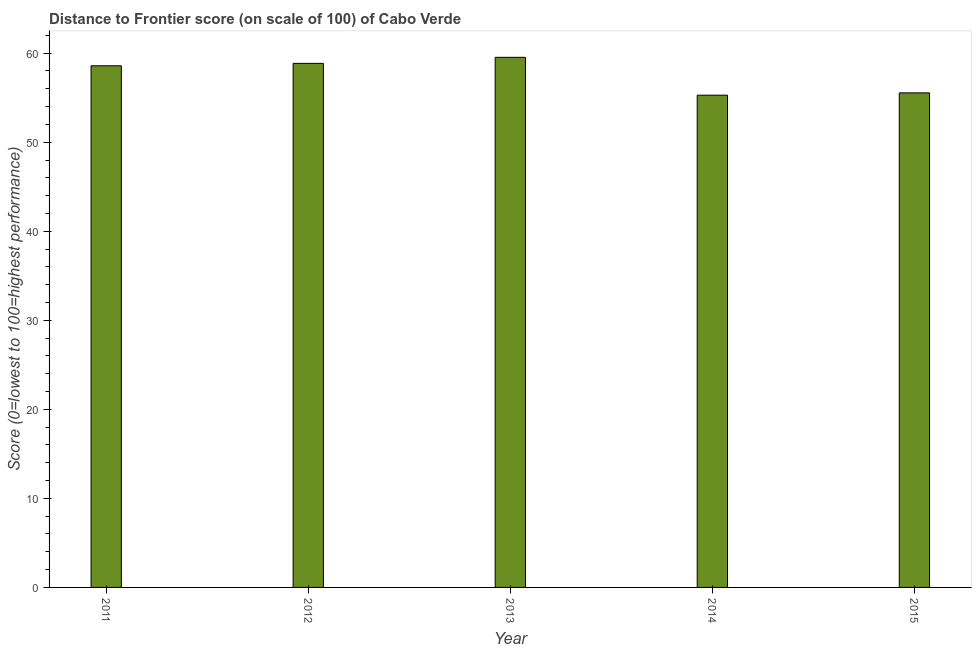Does the graph contain grids?
Your answer should be compact. No. What is the title of the graph?
Keep it short and to the point. Distance to Frontier score (on scale of 100) of Cabo Verde. What is the label or title of the X-axis?
Your answer should be very brief. Year. What is the label or title of the Y-axis?
Your answer should be compact. Score (0=lowest to 100=highest performance). What is the distance to frontier score in 2013?
Make the answer very short. 59.53. Across all years, what is the maximum distance to frontier score?
Your response must be concise. 59.53. Across all years, what is the minimum distance to frontier score?
Your response must be concise. 55.28. In which year was the distance to frontier score maximum?
Keep it short and to the point. 2013. In which year was the distance to frontier score minimum?
Provide a succinct answer. 2014. What is the sum of the distance to frontier score?
Provide a short and direct response. 287.78. What is the difference between the distance to frontier score in 2011 and 2012?
Your response must be concise. -0.27. What is the average distance to frontier score per year?
Your response must be concise. 57.56. What is the median distance to frontier score?
Keep it short and to the point. 58.58. In how many years, is the distance to frontier score greater than 12 ?
Your response must be concise. 5. Do a majority of the years between 2013 and 2012 (inclusive) have distance to frontier score greater than 48 ?
Offer a very short reply. No. What is the ratio of the distance to frontier score in 2011 to that in 2014?
Provide a short and direct response. 1.06. Is the difference between the distance to frontier score in 2013 and 2015 greater than the difference between any two years?
Give a very brief answer. No. What is the difference between the highest and the second highest distance to frontier score?
Provide a short and direct response. 0.68. Is the sum of the distance to frontier score in 2012 and 2015 greater than the maximum distance to frontier score across all years?
Provide a short and direct response. Yes. What is the difference between the highest and the lowest distance to frontier score?
Give a very brief answer. 4.25. In how many years, is the distance to frontier score greater than the average distance to frontier score taken over all years?
Ensure brevity in your answer.  3. Are all the bars in the graph horizontal?
Offer a very short reply. No. How many years are there in the graph?
Give a very brief answer. 5. What is the difference between two consecutive major ticks on the Y-axis?
Make the answer very short. 10. What is the Score (0=lowest to 100=highest performance) of 2011?
Give a very brief answer. 58.58. What is the Score (0=lowest to 100=highest performance) of 2012?
Ensure brevity in your answer.  58.85. What is the Score (0=lowest to 100=highest performance) in 2013?
Your response must be concise. 59.53. What is the Score (0=lowest to 100=highest performance) in 2014?
Offer a terse response. 55.28. What is the Score (0=lowest to 100=highest performance) of 2015?
Your answer should be compact. 55.54. What is the difference between the Score (0=lowest to 100=highest performance) in 2011 and 2012?
Your answer should be compact. -0.27. What is the difference between the Score (0=lowest to 100=highest performance) in 2011 and 2013?
Make the answer very short. -0.95. What is the difference between the Score (0=lowest to 100=highest performance) in 2011 and 2014?
Ensure brevity in your answer.  3.3. What is the difference between the Score (0=lowest to 100=highest performance) in 2011 and 2015?
Make the answer very short. 3.04. What is the difference between the Score (0=lowest to 100=highest performance) in 2012 and 2013?
Provide a succinct answer. -0.68. What is the difference between the Score (0=lowest to 100=highest performance) in 2012 and 2014?
Your answer should be very brief. 3.57. What is the difference between the Score (0=lowest to 100=highest performance) in 2012 and 2015?
Give a very brief answer. 3.31. What is the difference between the Score (0=lowest to 100=highest performance) in 2013 and 2014?
Your answer should be compact. 4.25. What is the difference between the Score (0=lowest to 100=highest performance) in 2013 and 2015?
Provide a succinct answer. 3.99. What is the difference between the Score (0=lowest to 100=highest performance) in 2014 and 2015?
Provide a succinct answer. -0.26. What is the ratio of the Score (0=lowest to 100=highest performance) in 2011 to that in 2012?
Provide a short and direct response. 0.99. What is the ratio of the Score (0=lowest to 100=highest performance) in 2011 to that in 2013?
Your response must be concise. 0.98. What is the ratio of the Score (0=lowest to 100=highest performance) in 2011 to that in 2014?
Your response must be concise. 1.06. What is the ratio of the Score (0=lowest to 100=highest performance) in 2011 to that in 2015?
Offer a terse response. 1.05. What is the ratio of the Score (0=lowest to 100=highest performance) in 2012 to that in 2014?
Keep it short and to the point. 1.06. What is the ratio of the Score (0=lowest to 100=highest performance) in 2012 to that in 2015?
Offer a very short reply. 1.06. What is the ratio of the Score (0=lowest to 100=highest performance) in 2013 to that in 2014?
Your response must be concise. 1.08. What is the ratio of the Score (0=lowest to 100=highest performance) in 2013 to that in 2015?
Provide a succinct answer. 1.07. 